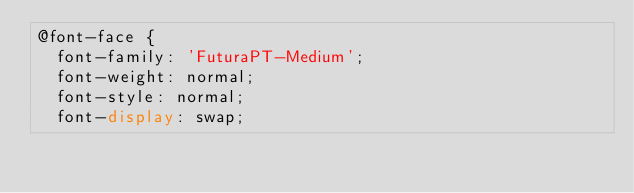Convert code to text. <code><loc_0><loc_0><loc_500><loc_500><_CSS_>@font-face {
  font-family: 'FuturaPT-Medium';
  font-weight: normal;
  font-style: normal;
  font-display: swap;</code> 